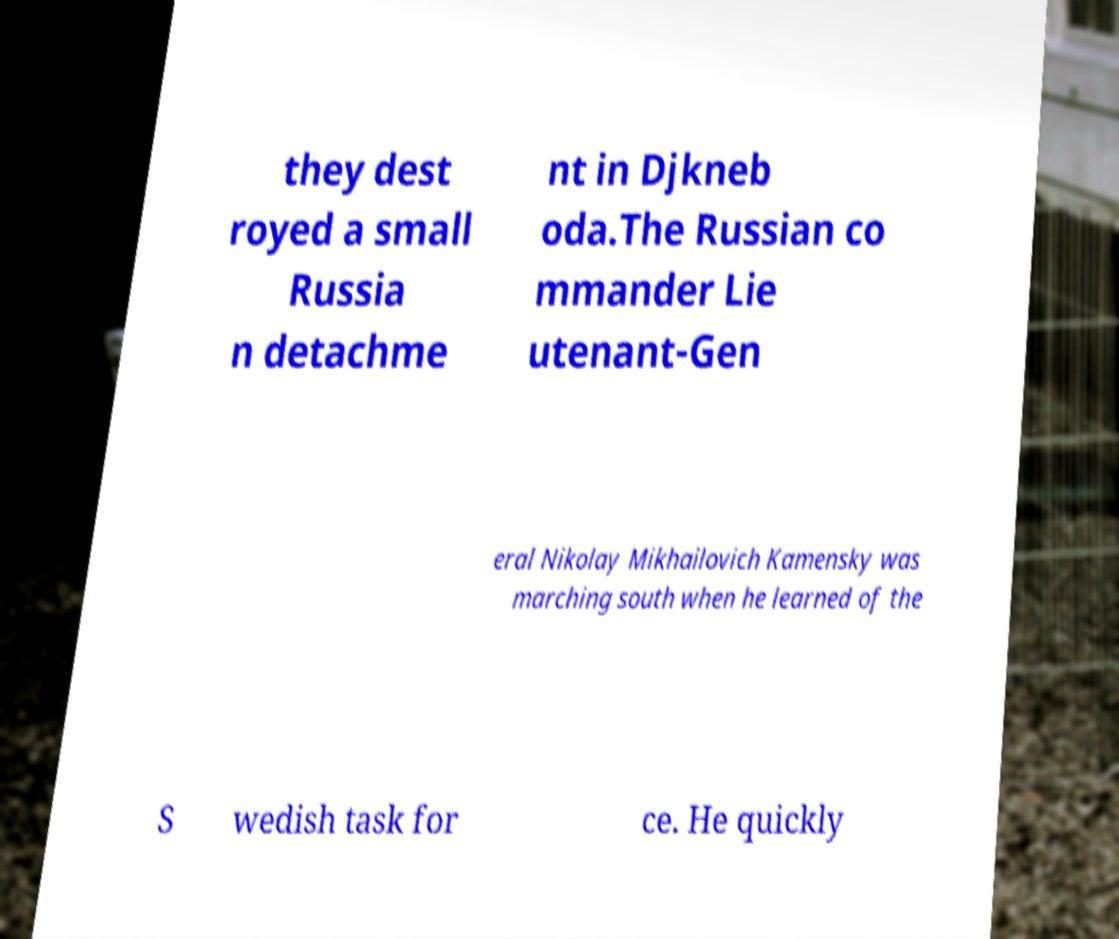I need the written content from this picture converted into text. Can you do that? they dest royed a small Russia n detachme nt in Djkneb oda.The Russian co mmander Lie utenant-Gen eral Nikolay Mikhailovich Kamensky was marching south when he learned of the S wedish task for ce. He quickly 